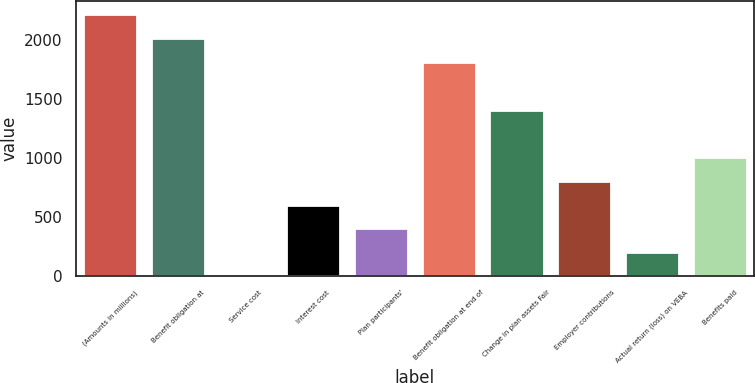<chart> <loc_0><loc_0><loc_500><loc_500><bar_chart><fcel>(Amounts in millions)<fcel>Benefit obligation at<fcel>Service cost<fcel>Interest cost<fcel>Plan participants'<fcel>Benefit obligation at end of<fcel>Change in plan assets Fair<fcel>Employer contributions<fcel>Actual return (loss) on VEBA<fcel>Benefits paid<nl><fcel>2212.08<fcel>2011<fcel>0.2<fcel>603.44<fcel>402.36<fcel>1809.92<fcel>1407.76<fcel>804.52<fcel>201.28<fcel>1005.6<nl></chart> 